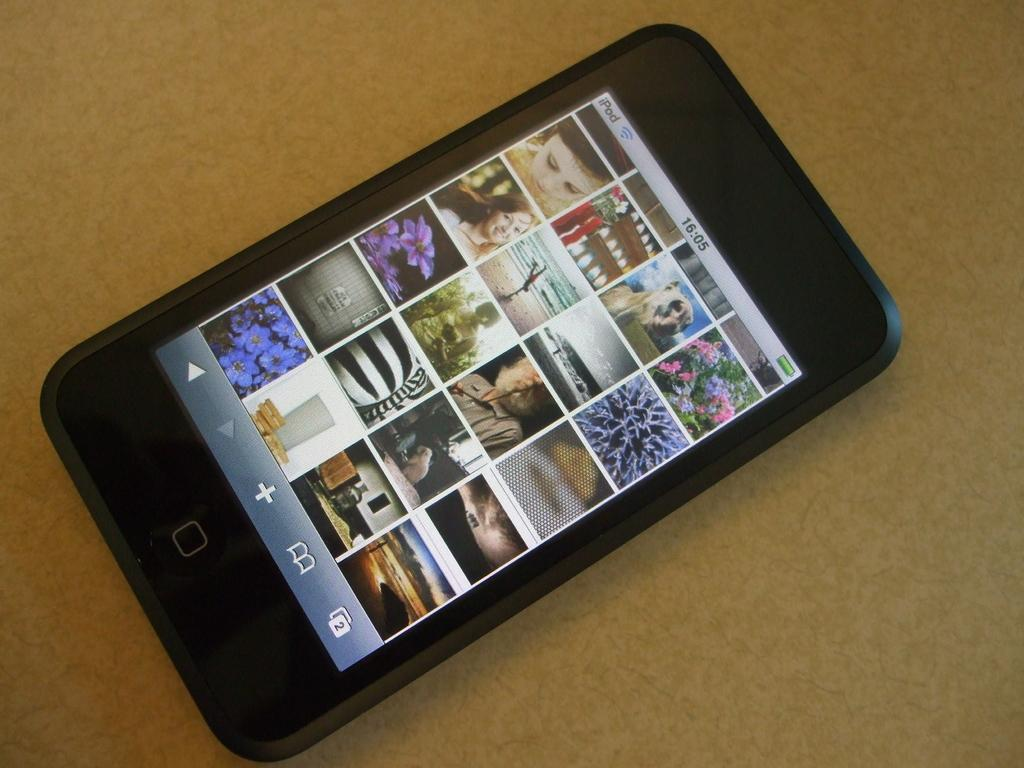What is the main subject of the picture? The main subject of the picture is an iPhone. Where is the iPhone located in the image? The iPhone is on a surface in the image. What can be seen on the iPhone's screen? The iPhone's screen displays pictures of persons, plants, trees, and other objects. What type of respect is shown towards the dinner in the image? There is no dinner present in the image, so it is not possible to determine if any respect is shown towards it. 